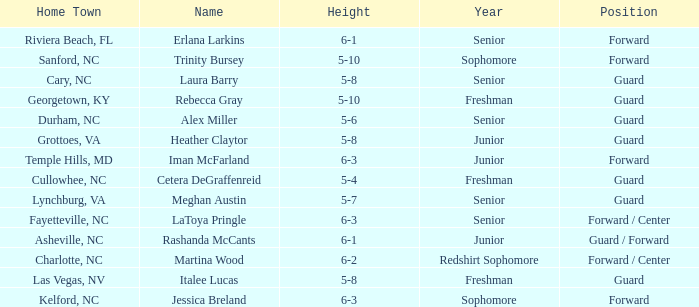In what year of school is the forward Iman McFarland? Junior. Parse the table in full. {'header': ['Home Town', 'Name', 'Height', 'Year', 'Position'], 'rows': [['Riviera Beach, FL', 'Erlana Larkins', '6-1', 'Senior', 'Forward'], ['Sanford, NC', 'Trinity Bursey', '5-10', 'Sophomore', 'Forward'], ['Cary, NC', 'Laura Barry', '5-8', 'Senior', 'Guard'], ['Georgetown, KY', 'Rebecca Gray', '5-10', 'Freshman', 'Guard'], ['Durham, NC', 'Alex Miller', '5-6', 'Senior', 'Guard'], ['Grottoes, VA', 'Heather Claytor', '5-8', 'Junior', 'Guard'], ['Temple Hills, MD', 'Iman McFarland', '6-3', 'Junior', 'Forward'], ['Cullowhee, NC', 'Cetera DeGraffenreid', '5-4', 'Freshman', 'Guard'], ['Lynchburg, VA', 'Meghan Austin', '5-7', 'Senior', 'Guard'], ['Fayetteville, NC', 'LaToya Pringle', '6-3', 'Senior', 'Forward / Center'], ['Asheville, NC', 'Rashanda McCants', '6-1', 'Junior', 'Guard / Forward'], ['Charlotte, NC', 'Martina Wood', '6-2', 'Redshirt Sophomore', 'Forward / Center'], ['Las Vegas, NV', 'Italee Lucas', '5-8', 'Freshman', 'Guard'], ['Kelford, NC', 'Jessica Breland', '6-3', 'Sophomore', 'Forward']]} 